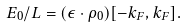<formula> <loc_0><loc_0><loc_500><loc_500>E _ { 0 } / L = ( \epsilon \cdot \rho _ { 0 } ) [ - k _ { F } , k _ { F } ] .</formula> 